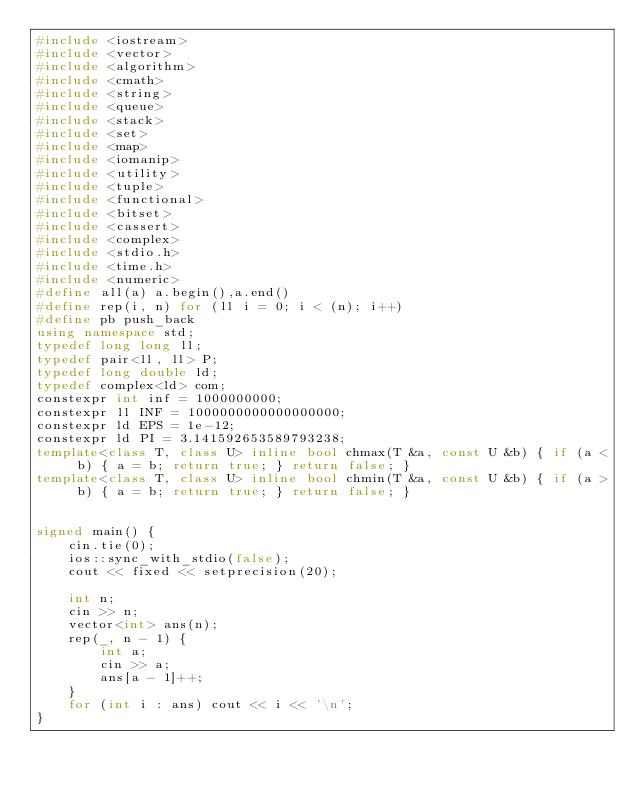<code> <loc_0><loc_0><loc_500><loc_500><_C++_>#include <iostream>
#include <vector>
#include <algorithm>
#include <cmath>
#include <string>
#include <queue>
#include <stack>
#include <set>
#include <map>
#include <iomanip>
#include <utility>
#include <tuple>
#include <functional>
#include <bitset>
#include <cassert>
#include <complex>
#include <stdio.h>
#include <time.h>
#include <numeric>
#define all(a) a.begin(),a.end()
#define rep(i, n) for (ll i = 0; i < (n); i++)
#define pb push_back
using namespace std;
typedef long long ll;
typedef pair<ll, ll> P;
typedef long double ld;
typedef complex<ld> com;
constexpr int inf = 1000000000;
constexpr ll INF = 1000000000000000000;
constexpr ld EPS = 1e-12;
constexpr ld PI = 3.141592653589793238;
template<class T, class U> inline bool chmax(T &a, const U &b) { if (a < b) { a = b; return true; } return false; }
template<class T, class U> inline bool chmin(T &a, const U &b) { if (a > b) { a = b; return true; } return false; }


signed main() {
	cin.tie(0);
	ios::sync_with_stdio(false);
	cout << fixed << setprecision(20);

	int n;
	cin >> n;
	vector<int> ans(n);
	rep(_, n - 1) {
		int a;
		cin >> a;
		ans[a - 1]++;
	}
	for (int i : ans) cout << i << '\n';
}</code> 